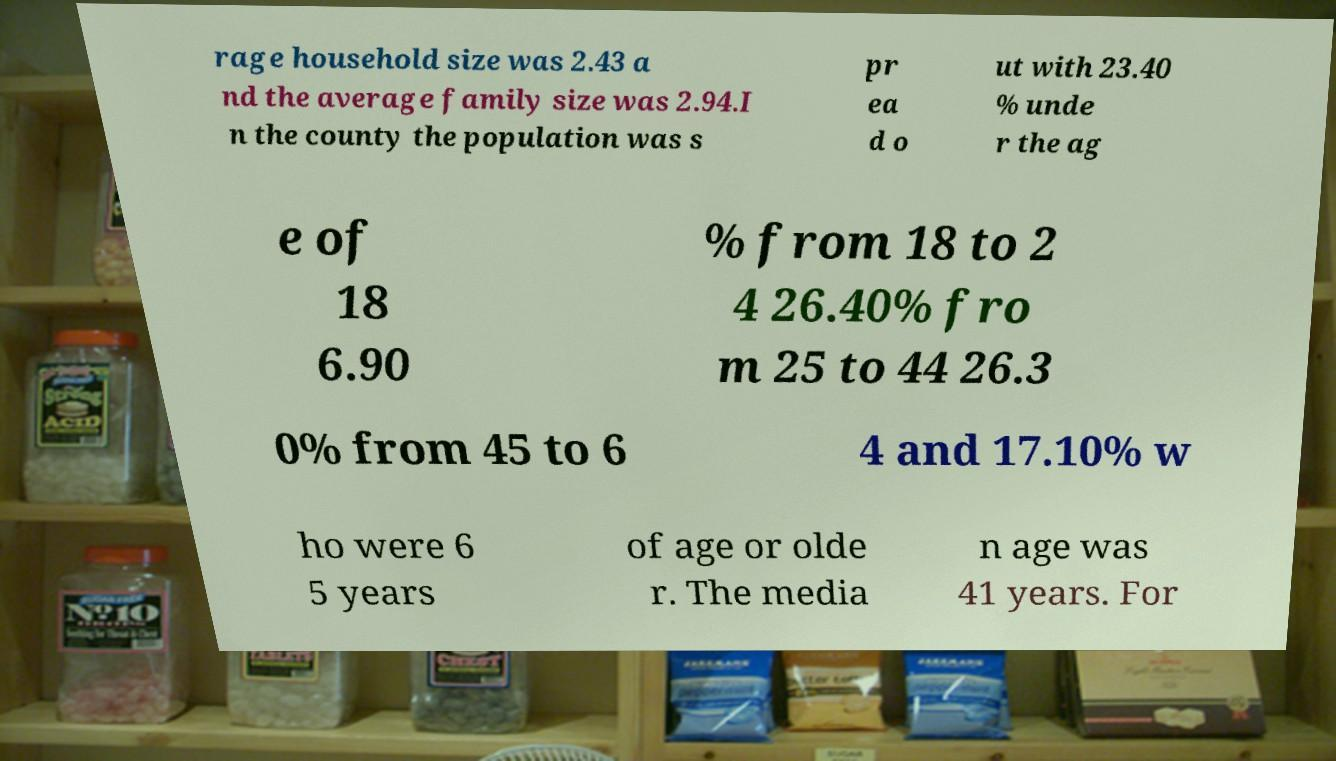Can you accurately transcribe the text from the provided image for me? rage household size was 2.43 a nd the average family size was 2.94.I n the county the population was s pr ea d o ut with 23.40 % unde r the ag e of 18 6.90 % from 18 to 2 4 26.40% fro m 25 to 44 26.3 0% from 45 to 6 4 and 17.10% w ho were 6 5 years of age or olde r. The media n age was 41 years. For 